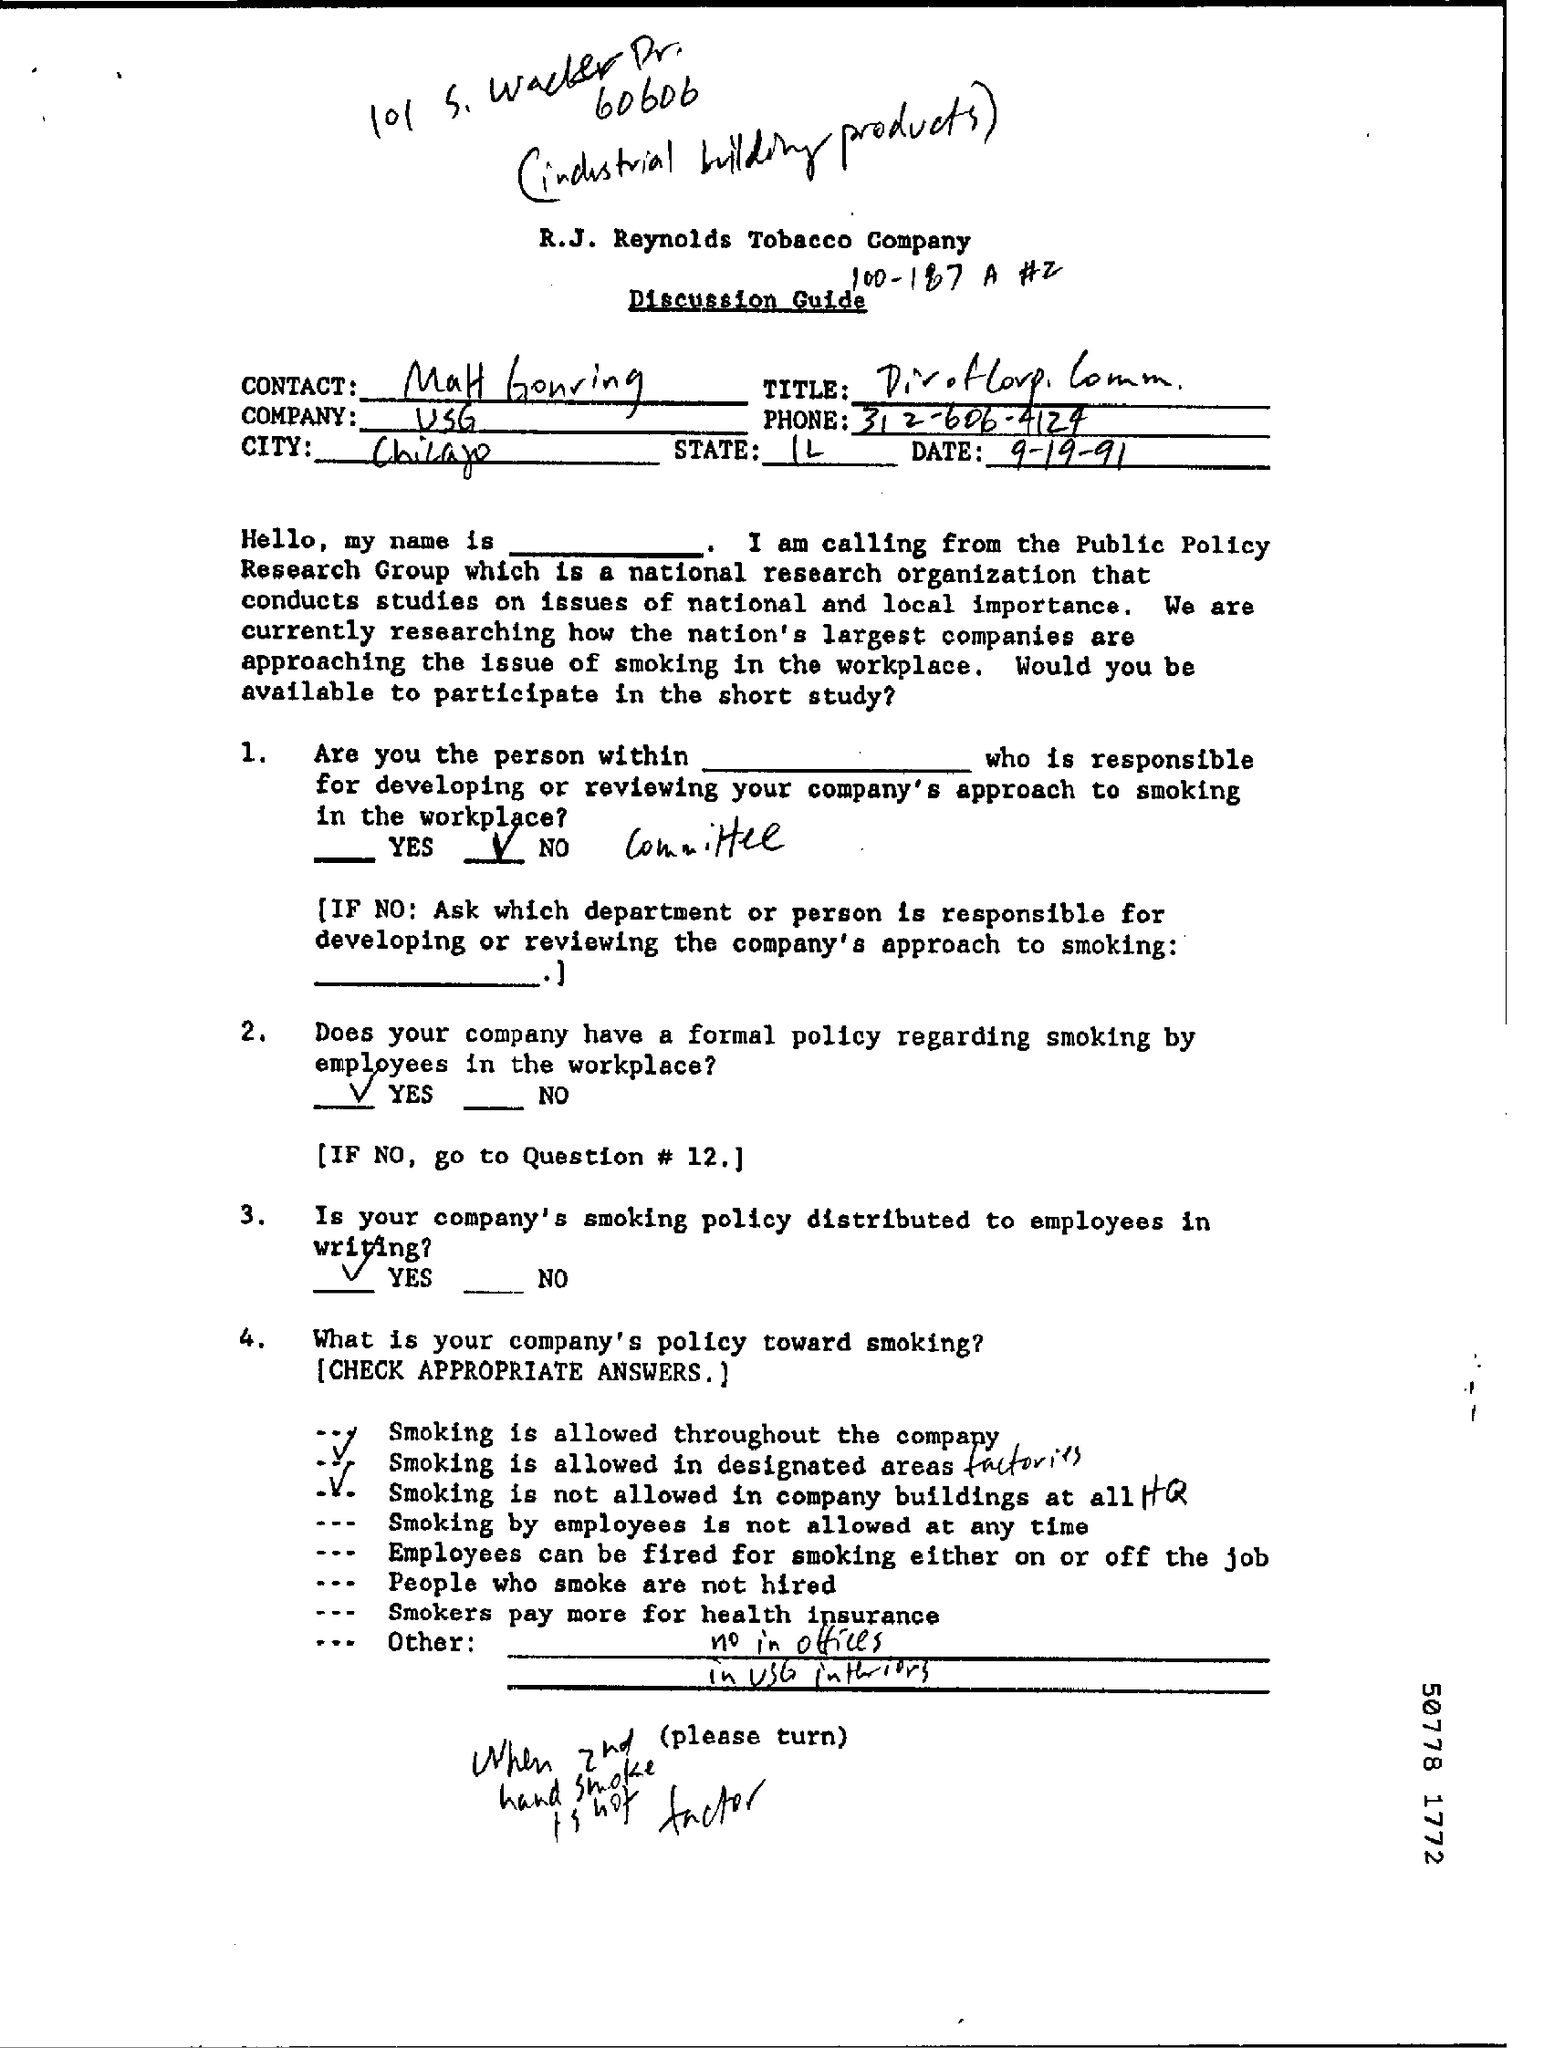What is the Title of the document?
Offer a very short reply. Discussion Guide. What is the Company?
Offer a very short reply. USG. What is the Phone?
Your answer should be very brief. 312-606-4124. What is the State?
Ensure brevity in your answer.  IL. What is the City?
Your response must be concise. Chicago. What is the Date?
Make the answer very short. 9-19-91. 